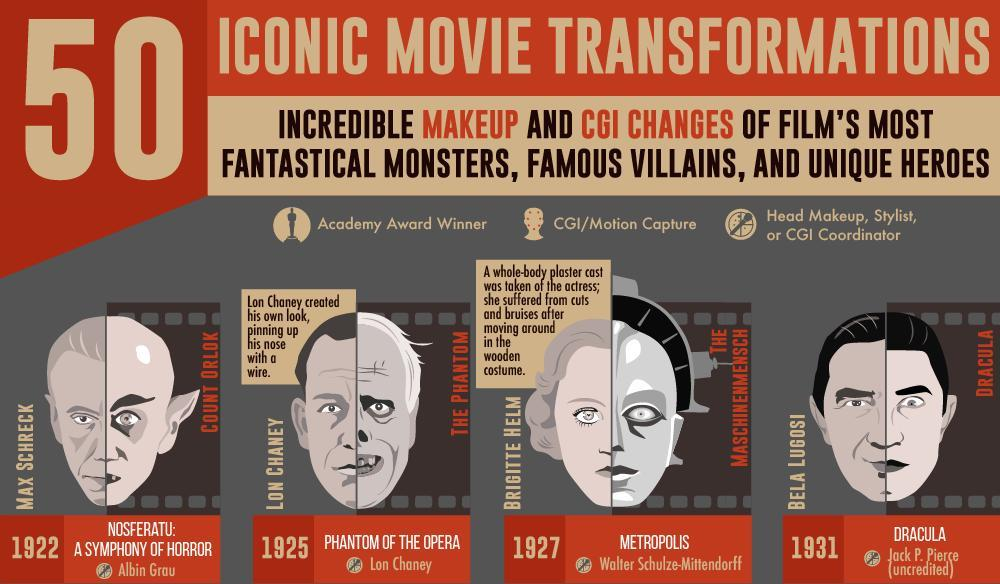Who was the Head Makeup or stylist for Metropolis?
Answer the question with a short phrase. Walter Schulze-Mittendorf When did Nosferatu release? 1922 Who suffered injuries due to costume? BRIGITTE HELM Who played Dracula in the movie? BELA LUGOSI What is the name of character in the movie Nosferatu? COUNT ORLOK Which movie had Brigitte Helm as the main actor? THE MASCHINENMENSCH 